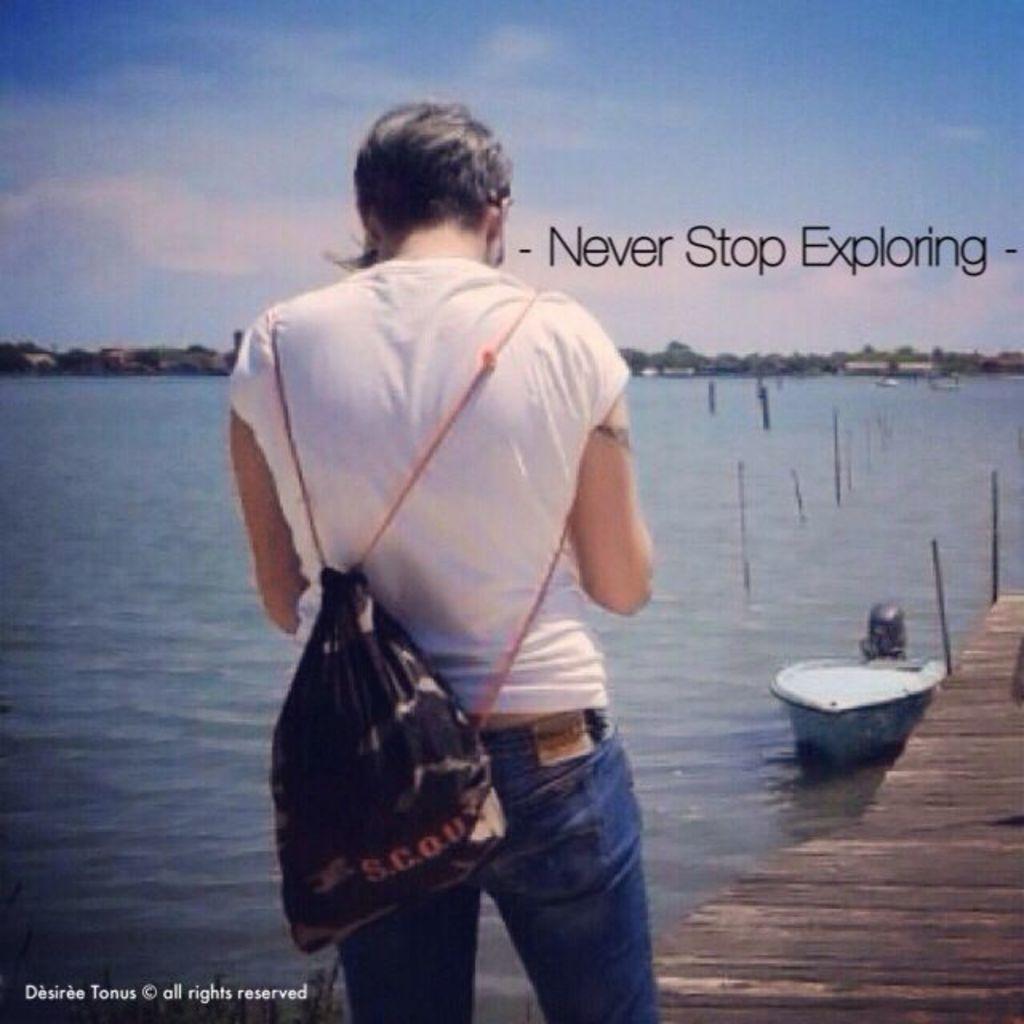Please provide a concise description of this image. In this image I can see a person standing on docks. I can see a boat on the water. I can see the water surface. At the top I can see clouds in the sky. I can see some text on the image. 